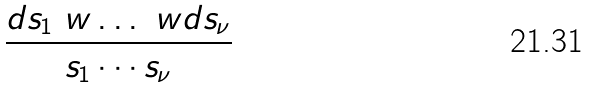<formula> <loc_0><loc_0><loc_500><loc_500>\frac { d s _ { 1 } \ w \dots \ w d s _ { \nu } } { s _ { 1 } \cdots s _ { \nu } }</formula> 